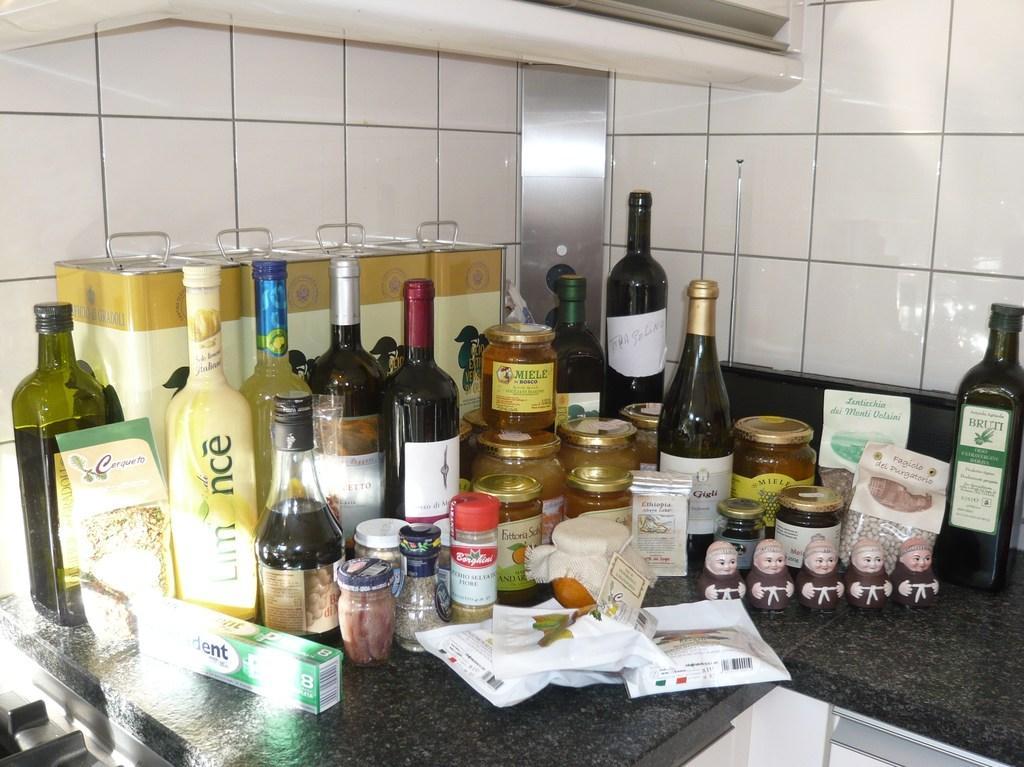Please provide a concise description of this image. On the counter table we can find bottles and some jars. There are also some packets. There is a toothpaste placed on a counter table behind the bottles there are some tins. In the background we can find tiles. 